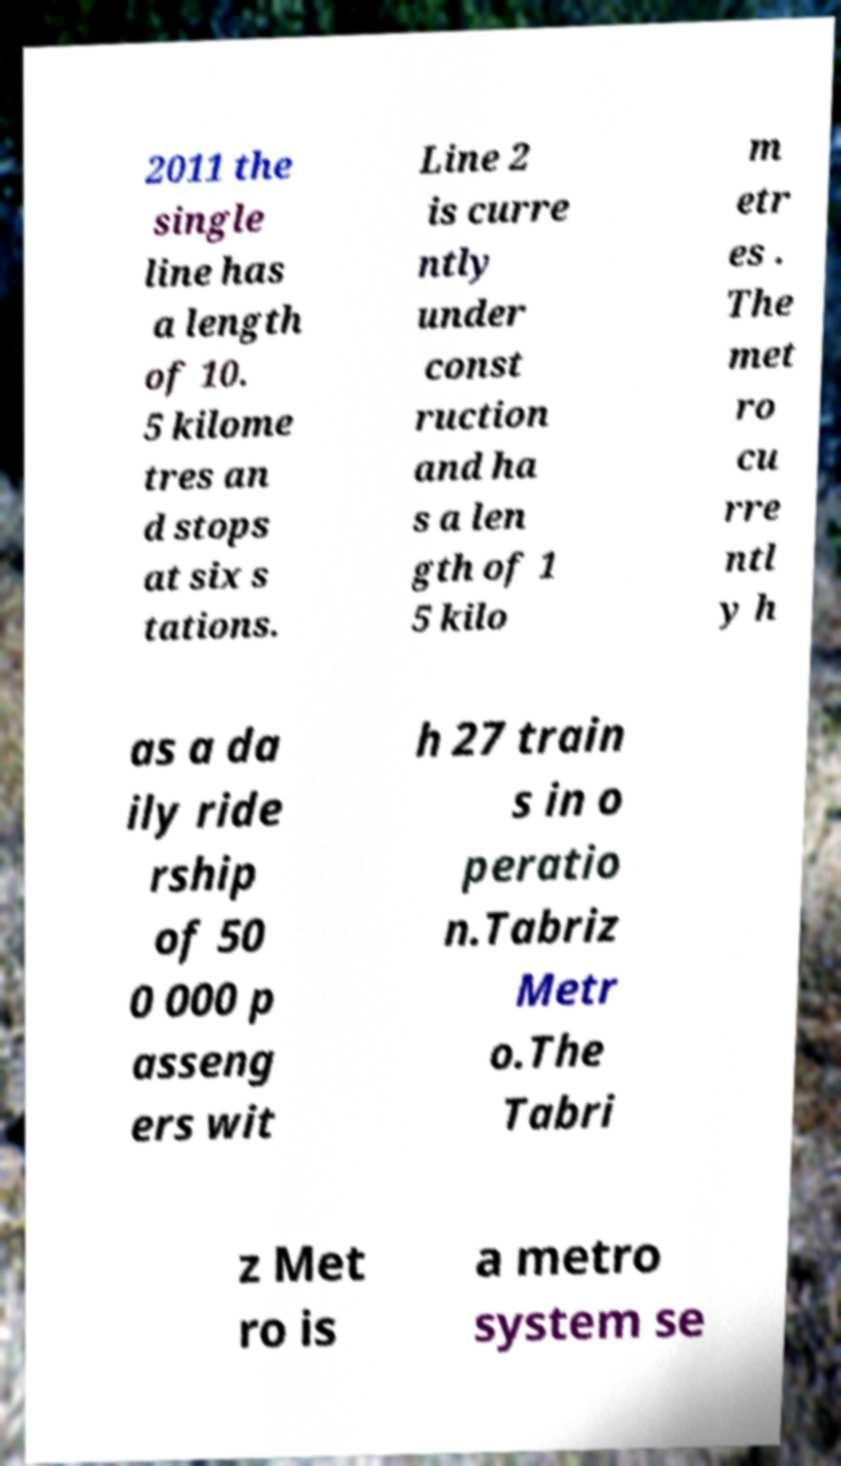Please identify and transcribe the text found in this image. 2011 the single line has a length of 10. 5 kilome tres an d stops at six s tations. Line 2 is curre ntly under const ruction and ha s a len gth of 1 5 kilo m etr es . The met ro cu rre ntl y h as a da ily ride rship of 50 0 000 p asseng ers wit h 27 train s in o peratio n.Tabriz Metr o.The Tabri z Met ro is a metro system se 